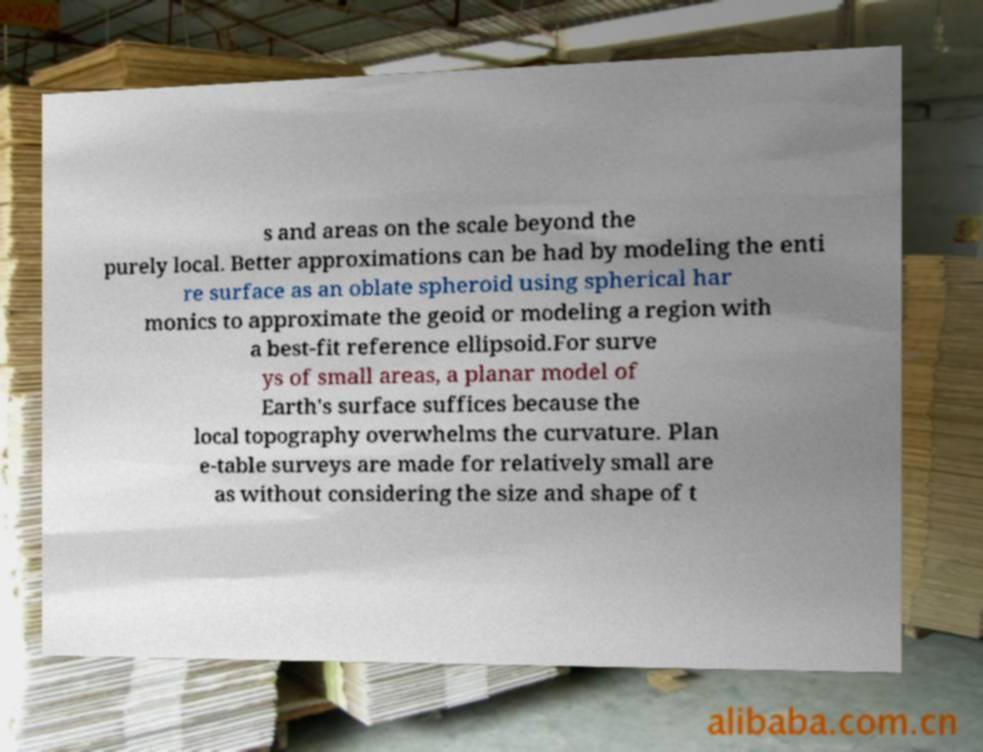There's text embedded in this image that I need extracted. Can you transcribe it verbatim? s and areas on the scale beyond the purely local. Better approximations can be had by modeling the enti re surface as an oblate spheroid using spherical har monics to approximate the geoid or modeling a region with a best-fit reference ellipsoid.For surve ys of small areas, a planar model of Earth's surface suffices because the local topography overwhelms the curvature. Plan e-table surveys are made for relatively small are as without considering the size and shape of t 